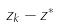<formula> <loc_0><loc_0><loc_500><loc_500>z _ { k } - z ^ { * }</formula> 